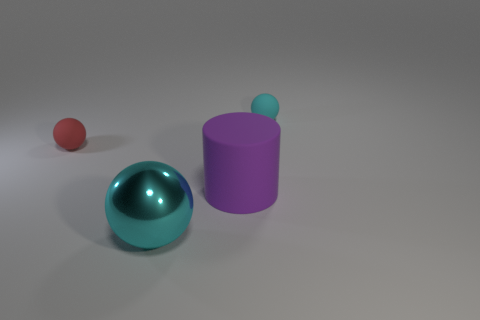What is the size of the matte ball on the left side of the big rubber object?
Offer a very short reply. Small. What is the size of the other ball that is the same color as the large sphere?
Give a very brief answer. Small. Are there any other small red objects that have the same material as the red thing?
Your answer should be very brief. No. Is the material of the large cyan ball the same as the small red ball?
Provide a succinct answer. No. What color is the ball that is the same size as the purple matte object?
Provide a succinct answer. Cyan. How many other things are there of the same shape as the shiny thing?
Provide a succinct answer. 2. There is a purple matte object; does it have the same size as the sphere behind the tiny red rubber sphere?
Your response must be concise. No. What number of objects are either cyan rubber things or large gray matte balls?
Provide a succinct answer. 1. How many other things are the same size as the cyan rubber object?
Make the answer very short. 1. There is a metallic sphere; does it have the same color as the matte sphere that is to the left of the large cyan metallic sphere?
Make the answer very short. No. 